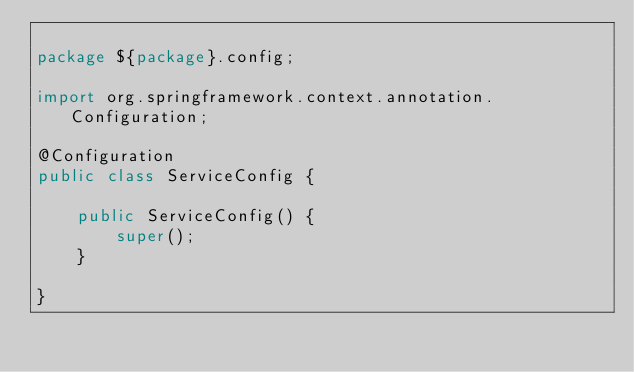Convert code to text. <code><loc_0><loc_0><loc_500><loc_500><_Java_>
package ${package}.config;

import org.springframework.context.annotation.Configuration;

@Configuration
public class ServiceConfig {

    public ServiceConfig() {
        super();
    }

}
</code> 